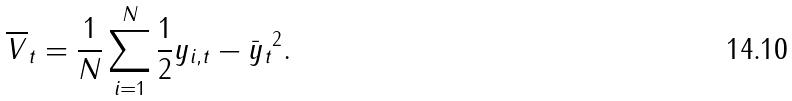Convert formula to latex. <formula><loc_0><loc_0><loc_500><loc_500>\overline { V } _ { t } = \frac { 1 } { N } \sum _ { i = 1 } ^ { N } \frac { 1 } { 2 } \| y _ { i , t } - \bar { y } _ { t } \| ^ { 2 } .</formula> 